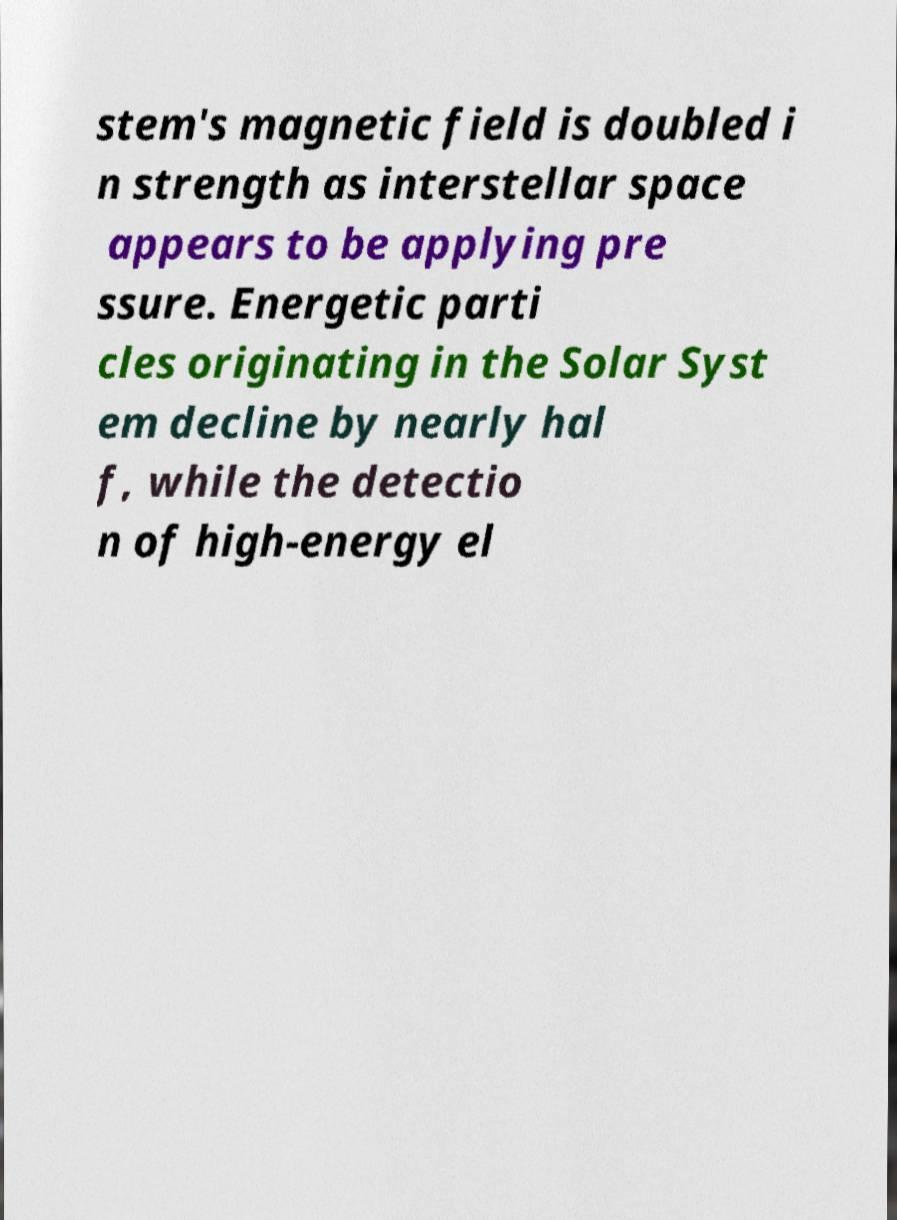Could you extract and type out the text from this image? stem's magnetic field is doubled i n strength as interstellar space appears to be applying pre ssure. Energetic parti cles originating in the Solar Syst em decline by nearly hal f, while the detectio n of high-energy el 